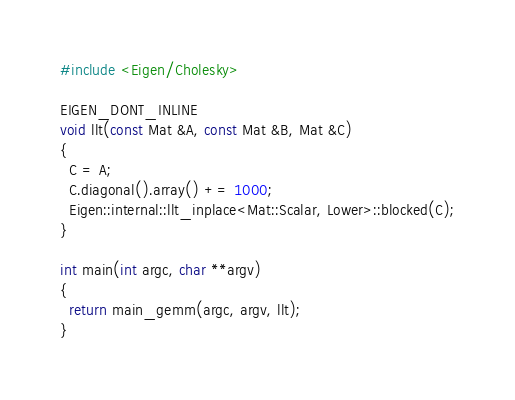Convert code to text. <code><loc_0><loc_0><loc_500><loc_500><_C++_>#include <Eigen/Cholesky>

EIGEN_DONT_INLINE
void llt(const Mat &A, const Mat &B, Mat &C)
{
  C = A;
  C.diagonal().array() += 1000;
  Eigen::internal::llt_inplace<Mat::Scalar, Lower>::blocked(C);
}

int main(int argc, char **argv)
{
  return main_gemm(argc, argv, llt);
}
</code> 